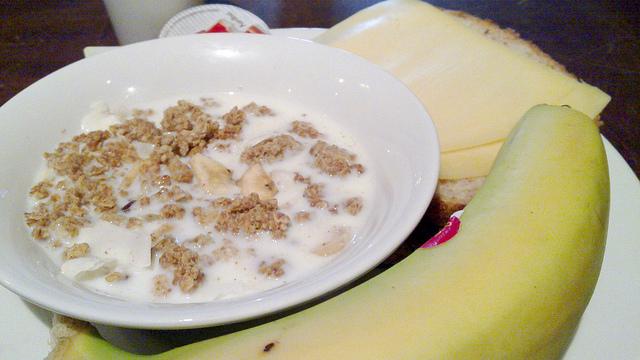What is in the bowl?
Give a very brief answer. Cereal. What are they likely celebrating?
Short answer required. Breakfast. Is this a balanced breakfast?
Keep it brief. Yes. What color is the banana peel?
Short answer required. Yellow. What kind of fruit is next to the bowl?
Quick response, please. Banana. 